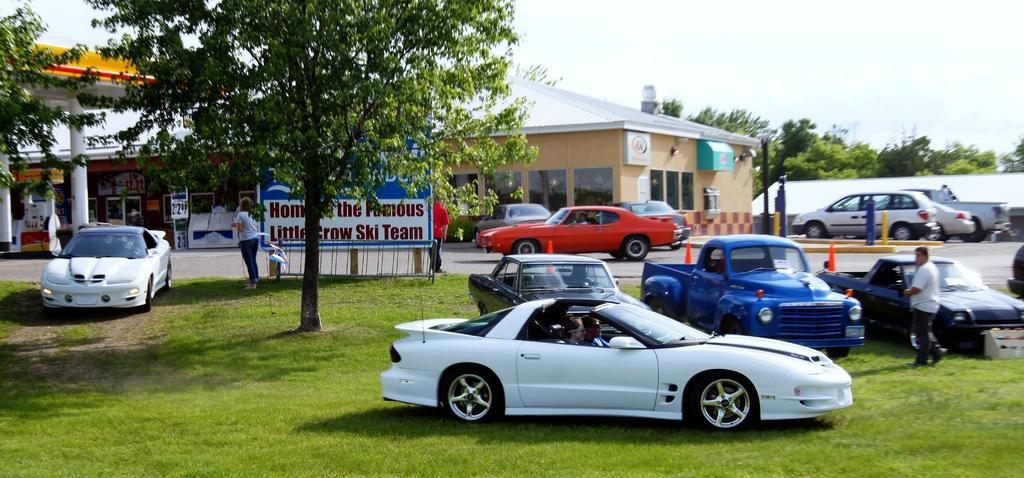Describe this image in one or two sentences. In the image we can see there are many vehicles of different colors. There are even people standing and wearing clothes. Here we can see the grass, trees, poles and the sky. Here we can see the building and the poster and we can see the text on the poster. 